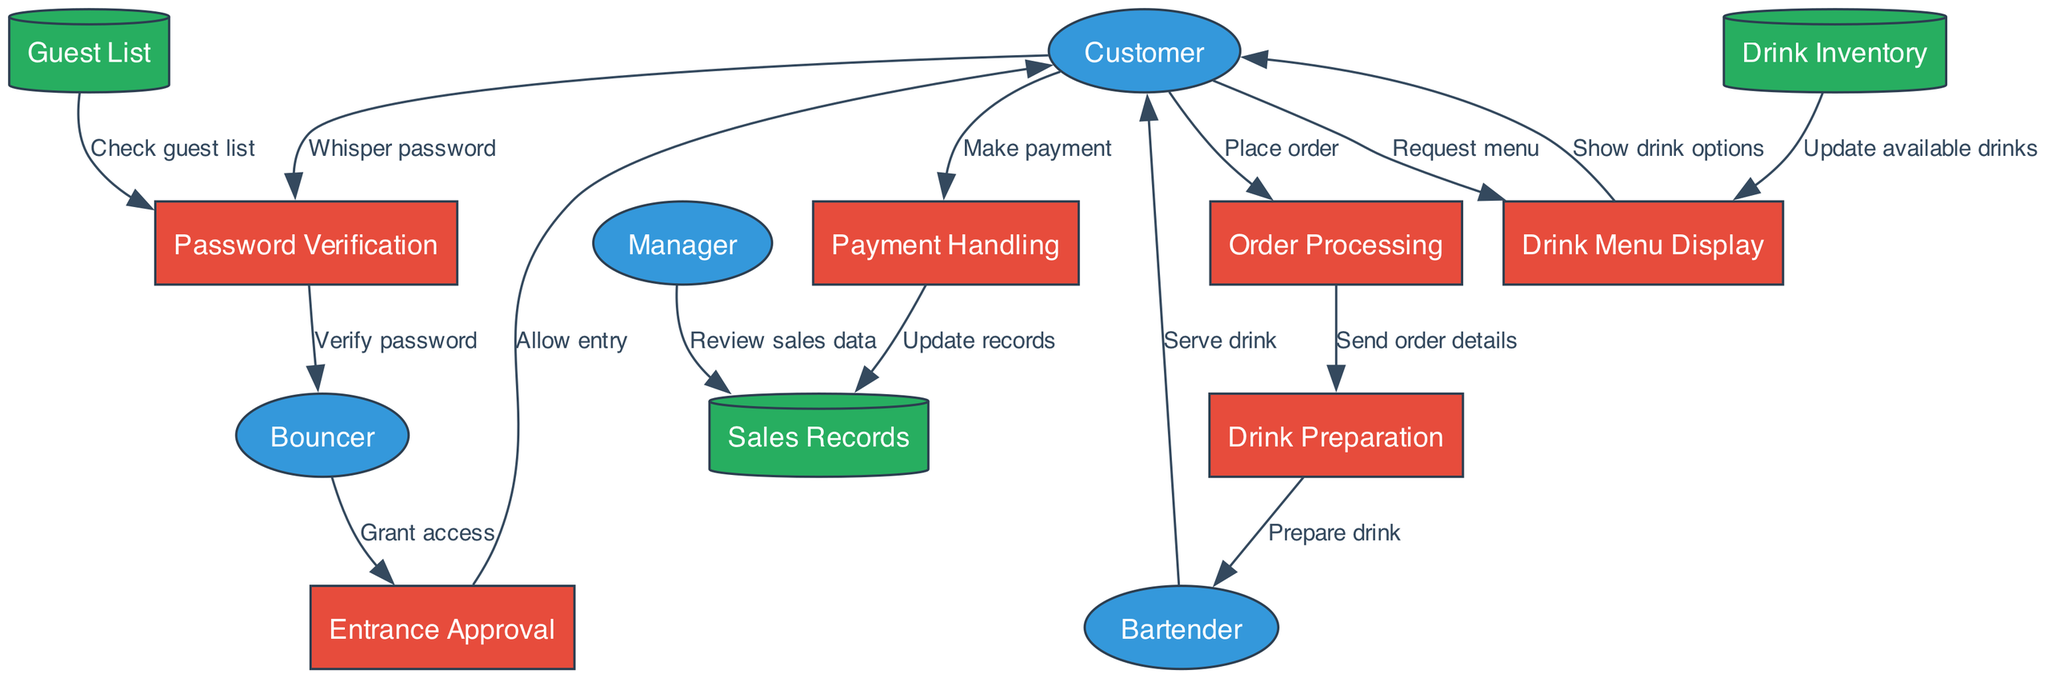What are the external entities in the diagram? The diagram lists four external entities: Customer, Bouncer, Bartender, and Manager. These represent the individuals or roles that interact with the processes in the speakeasy experience.
Answer: Customer, Bouncer, Bartender, Manager How many processes are depicted in the diagram? The diagram includes six distinct processes: Password Verification, Entrance Approval, Drink Menu Display, Order Processing, Drink Preparation, and Payment Handling. By counting each labeled rectangle representing a process, we confirm the total number.
Answer: 6 Which data store is checked during password verification? The "Guest List" data store is specifically checked during the "Password Verification" process to confirm if the customer is permitted entry based on their password.
Answer: Guest List What flow indicates the drink preparation step? The flow labeled "Send order details" from "Order Processing" to "Drink Preparation" indicates the step where the order details are communicated to prepare the customer's drink.
Answer: Send order details Which entity serves the drink to the customer? The "Bartender" is the entity responsible for serving the drink to the customer after it has been prepared. This is shown by the flow labeled "Serve drink" directed from Bartender to Customer.
Answer: Bartender What is updated after payment handling? After the "Payment Handling" process, the "Sales Records" data store is updated to reflect the transaction. This update is represented by the flow labeled "Update records."
Answer: Sales Records Which two processes are connected by the flow labeled "Whisper password"? The "Whisper password" flow connects the "Customer" and "Password Verification" processes, indicating that the customer provides their password for verification at the start of their journey.
Answer: Customer, Password Verification How is the drink menu displayed to the customer? The "Drink Menu Display" process conveys the available drinks to the customer via the flow labeled "Show drink options." This occurs after the customer requests to see the menu.
Answer: Show drink options What action does the bouncer take after verifying a password? After the password is verified, the bouncer takes the action indicated by the flow labeled "Grant access" to approve the customer's entrance into the speakeasy.
Answer: Grant access 